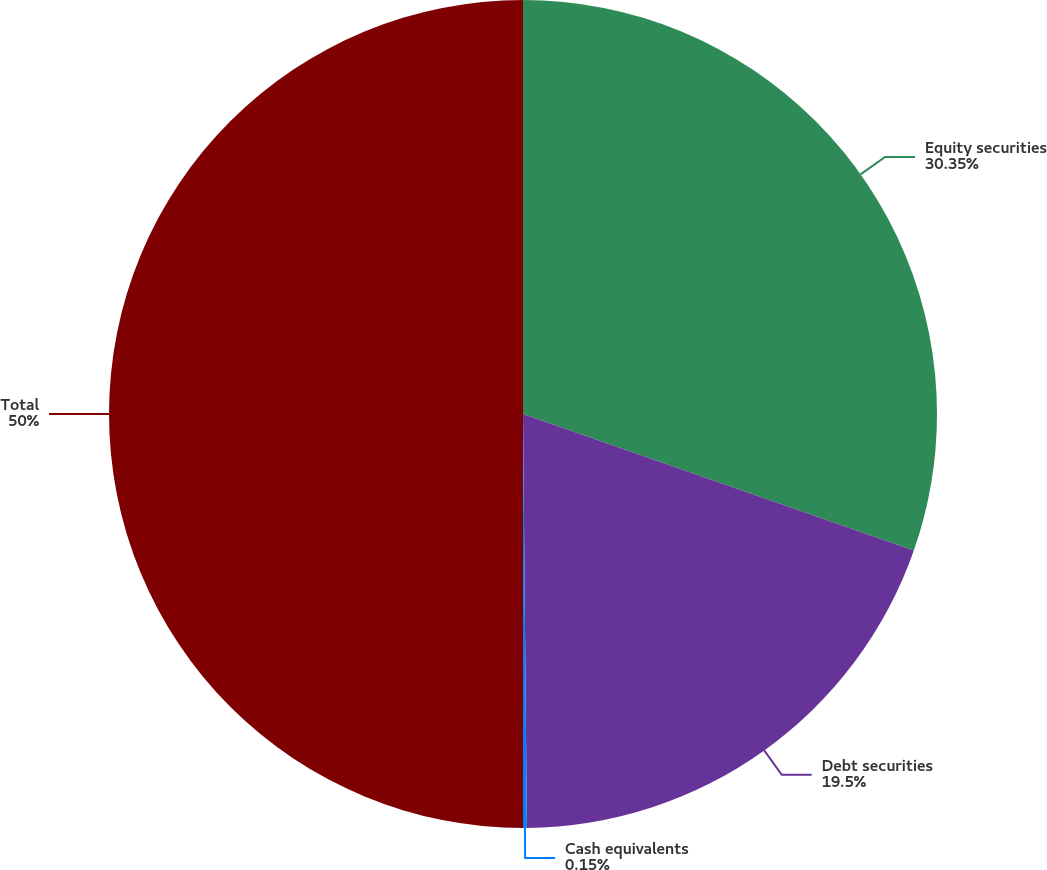Convert chart to OTSL. <chart><loc_0><loc_0><loc_500><loc_500><pie_chart><fcel>Equity securities<fcel>Debt securities<fcel>Cash equivalents<fcel>Total<nl><fcel>30.35%<fcel>19.5%<fcel>0.15%<fcel>50.0%<nl></chart> 